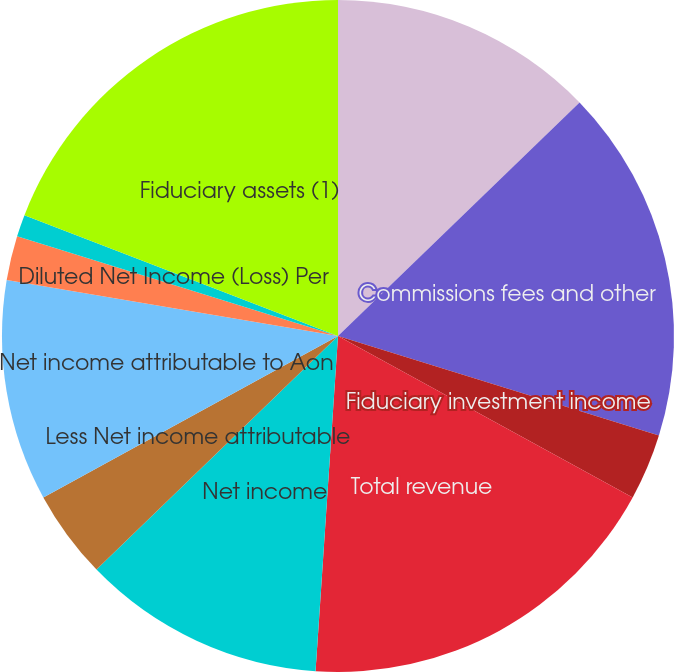Convert chart to OTSL. <chart><loc_0><loc_0><loc_500><loc_500><pie_chart><fcel>(millions except shareholders<fcel>Commissions fees and other<fcel>Fiduciary investment income<fcel>Total revenue<fcel>Net income<fcel>Less Net income attributable<fcel>Net income attributable to Aon<fcel>Basic Net Income (Loss) Per<fcel>Diluted Net Income (Loss) Per<fcel>Fiduciary assets (1)<nl><fcel>12.77%<fcel>17.02%<fcel>3.19%<fcel>18.09%<fcel>11.7%<fcel>4.26%<fcel>10.64%<fcel>2.13%<fcel>1.06%<fcel>19.15%<nl></chart> 